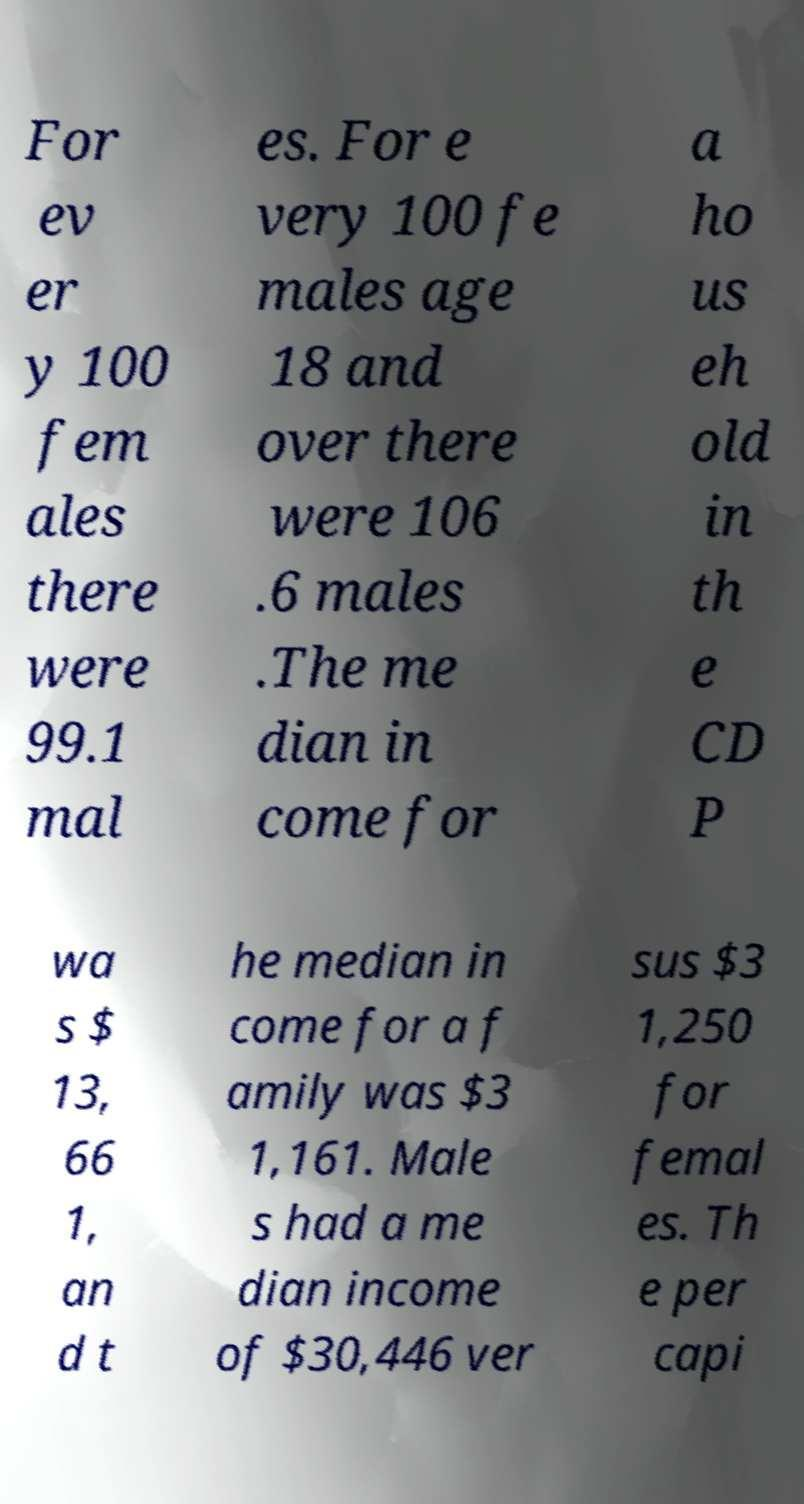There's text embedded in this image that I need extracted. Can you transcribe it verbatim? For ev er y 100 fem ales there were 99.1 mal es. For e very 100 fe males age 18 and over there were 106 .6 males .The me dian in come for a ho us eh old in th e CD P wa s $ 13, 66 1, an d t he median in come for a f amily was $3 1,161. Male s had a me dian income of $30,446 ver sus $3 1,250 for femal es. Th e per capi 